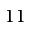Convert formula to latex. <formula><loc_0><loc_0><loc_500><loc_500>1 1</formula> 